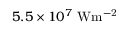<formula> <loc_0><loc_0><loc_500><loc_500>5 . 5 \times 1 0 ^ { 7 } \ W m ^ { - 2 }</formula> 